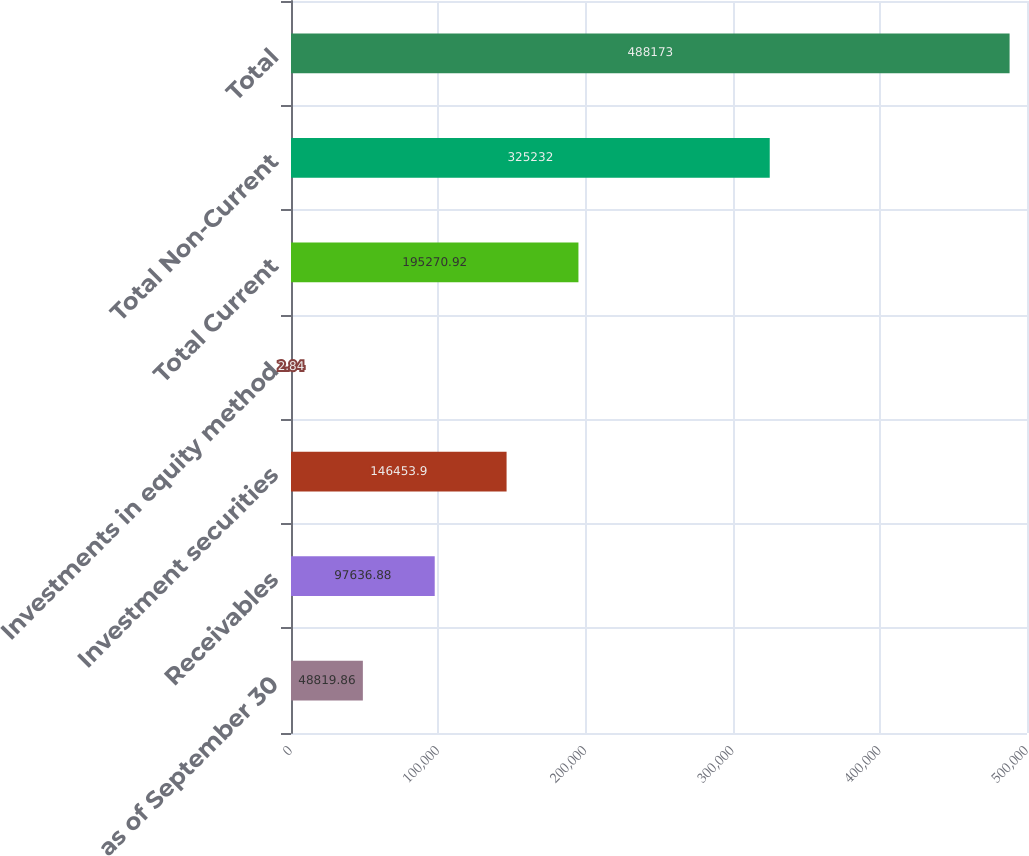Convert chart. <chart><loc_0><loc_0><loc_500><loc_500><bar_chart><fcel>as of September 30<fcel>Receivables<fcel>Investment securities<fcel>Investments in equity method<fcel>Total Current<fcel>Total Non-Current<fcel>Total<nl><fcel>48819.9<fcel>97636.9<fcel>146454<fcel>2.84<fcel>195271<fcel>325232<fcel>488173<nl></chart> 